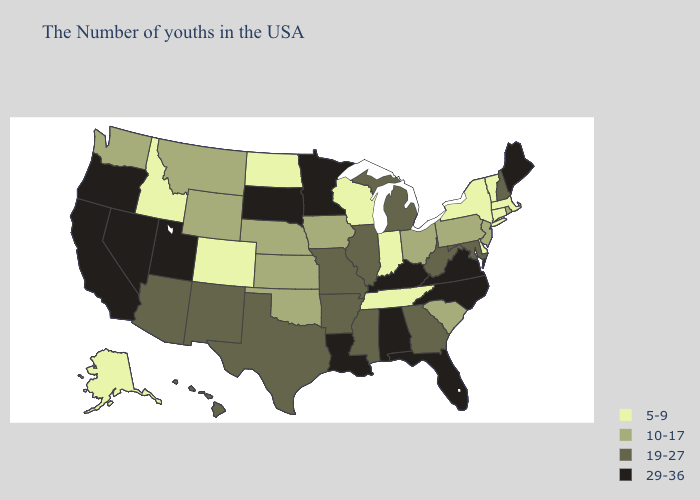What is the lowest value in states that border South Carolina?
Be succinct. 19-27. What is the lowest value in the South?
Short answer required. 5-9. What is the highest value in states that border Oregon?
Short answer required. 29-36. Does Tennessee have the same value as Nebraska?
Write a very short answer. No. What is the value of Florida?
Write a very short answer. 29-36. Name the states that have a value in the range 29-36?
Keep it brief. Maine, Virginia, North Carolina, Florida, Kentucky, Alabama, Louisiana, Minnesota, South Dakota, Utah, Nevada, California, Oregon. Which states have the highest value in the USA?
Short answer required. Maine, Virginia, North Carolina, Florida, Kentucky, Alabama, Louisiana, Minnesota, South Dakota, Utah, Nevada, California, Oregon. Name the states that have a value in the range 19-27?
Be succinct. New Hampshire, Maryland, West Virginia, Georgia, Michigan, Illinois, Mississippi, Missouri, Arkansas, Texas, New Mexico, Arizona, Hawaii. Does Ohio have the highest value in the USA?
Keep it brief. No. Does New Jersey have the highest value in the Northeast?
Quick response, please. No. Does Missouri have the highest value in the USA?
Quick response, please. No. Among the states that border Arkansas , does Louisiana have the lowest value?
Concise answer only. No. Among the states that border New Mexico , does Oklahoma have the lowest value?
Short answer required. No. Does Colorado have a higher value than Texas?
Answer briefly. No. What is the value of Alaska?
Short answer required. 5-9. 